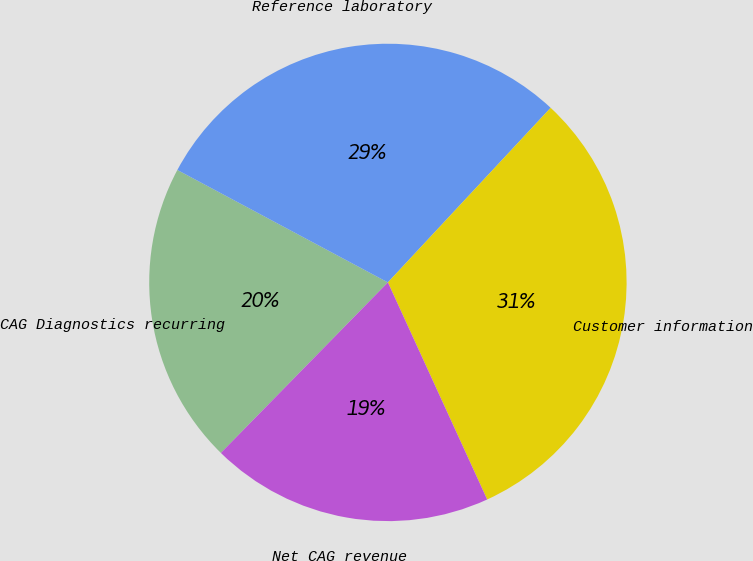<chart> <loc_0><loc_0><loc_500><loc_500><pie_chart><fcel>CAG Diagnostics recurring<fcel>Reference laboratory<fcel>Customer information<fcel>Net CAG revenue<nl><fcel>20.47%<fcel>29.13%<fcel>31.23%<fcel>19.16%<nl></chart> 